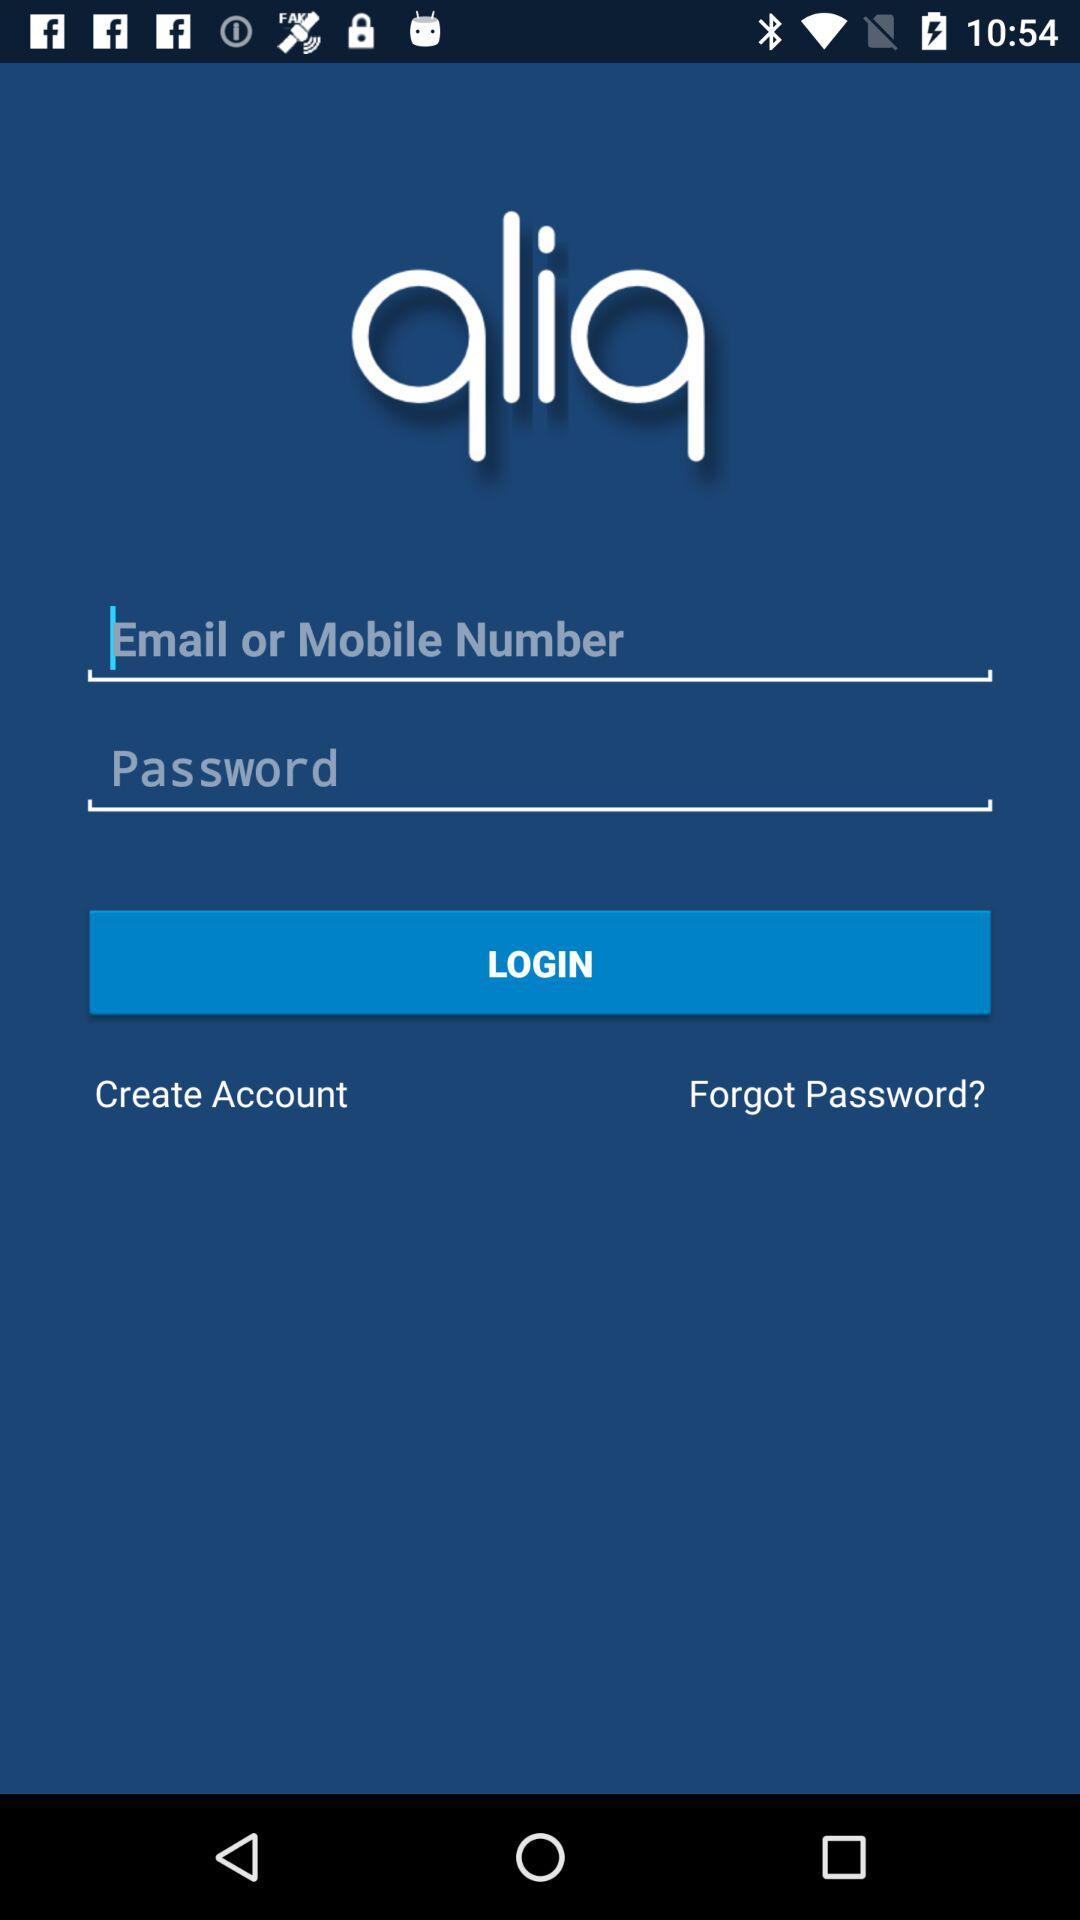Which email address is used for the account?
When the provided information is insufficient, respond with <no answer>. <no answer> 